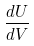Convert formula to latex. <formula><loc_0><loc_0><loc_500><loc_500>\frac { d U } { d V }</formula> 